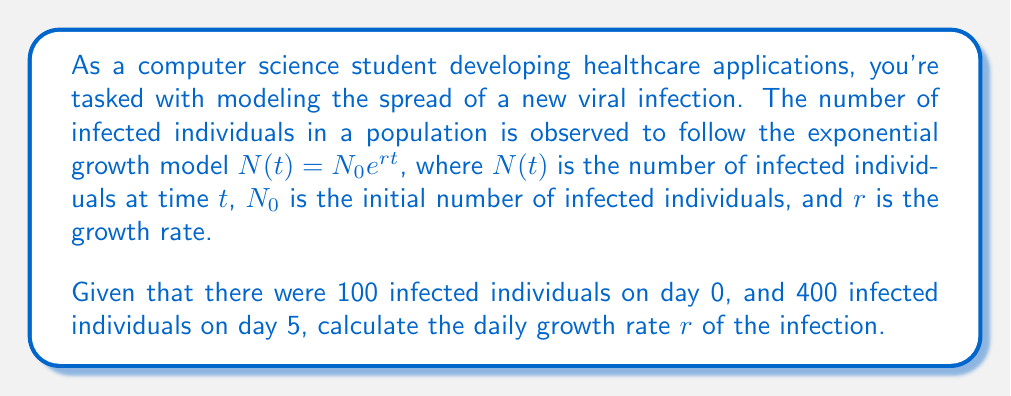Help me with this question. To solve this problem, we'll use the exponential growth model and the given data points:

1. We know that $N_0 = 100$ (initial number of infected individuals)
2. At $t = 5$ days, $N(5) = 400$

Let's plug these values into the exponential growth equation:

$$400 = 100 e^{5r}$$

Now, we'll solve for $r$:

1. Divide both sides by 100:
   $$4 = e^{5r}$$

2. Take the natural logarithm of both sides:
   $$\ln(4) = \ln(e^{5r})$$

3. Simplify the right side using the properties of logarithms:
   $$\ln(4) = 5r$$

4. Divide both sides by 5:
   $$\frac{\ln(4)}{5} = r$$

5. Calculate the final value:
   $$r = \frac{\ln(4)}{5} \approx 0.2773$$

This value represents the daily growth rate of the infection.
Answer: $r \approx 0.2773$ or approximately 27.73% per day 